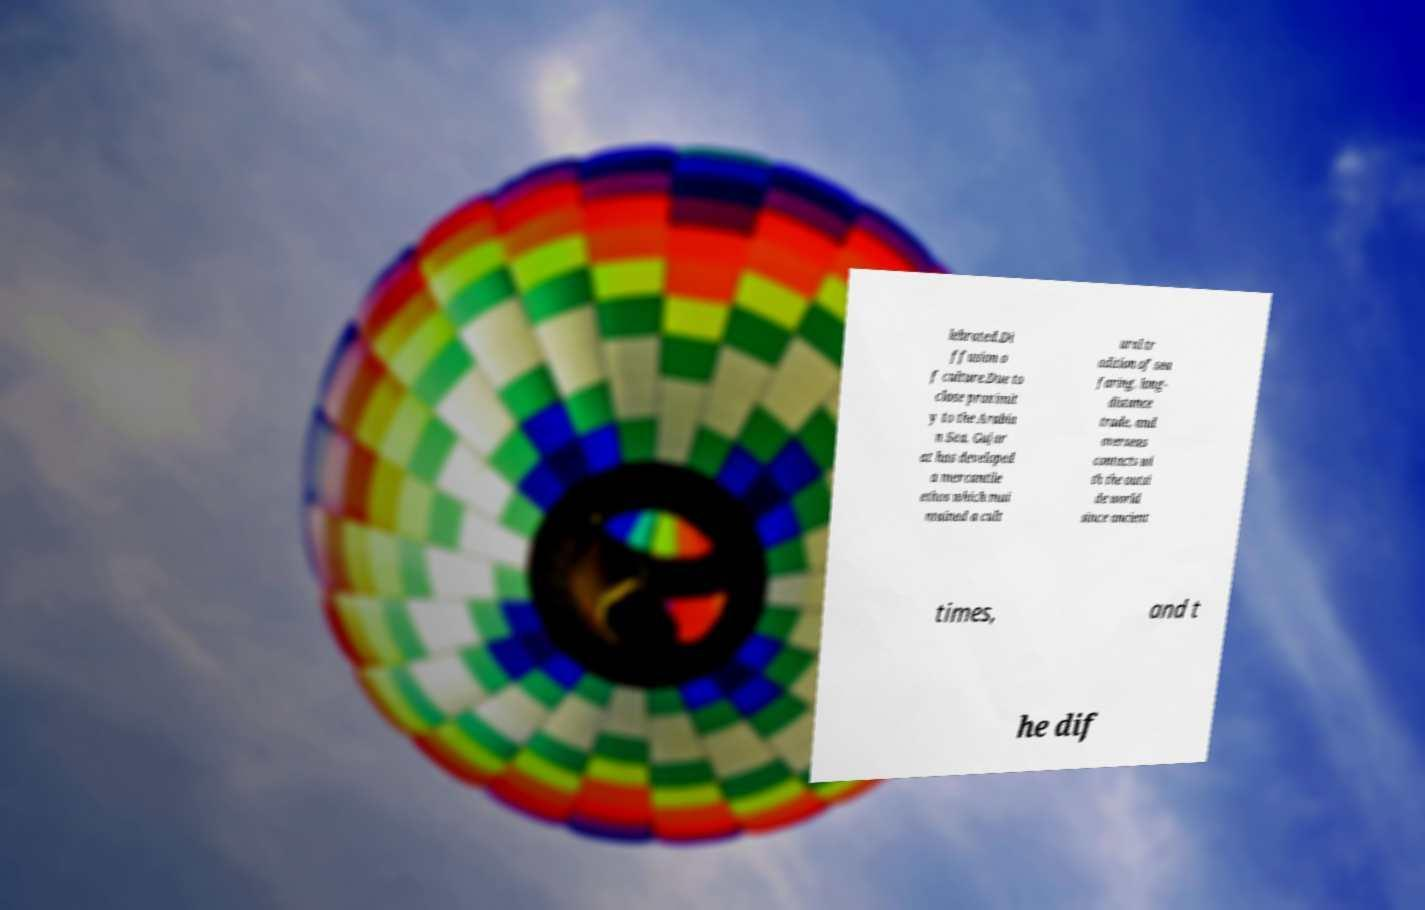There's text embedded in this image that I need extracted. Can you transcribe it verbatim? lebrated.Di ffusion o f culture.Due to close proximit y to the Arabia n Sea, Gujar at has developed a mercantile ethos which mai ntained a cult ural tr adition of sea faring, long- distance trade, and overseas contacts wi th the outsi de world since ancient times, and t he dif 